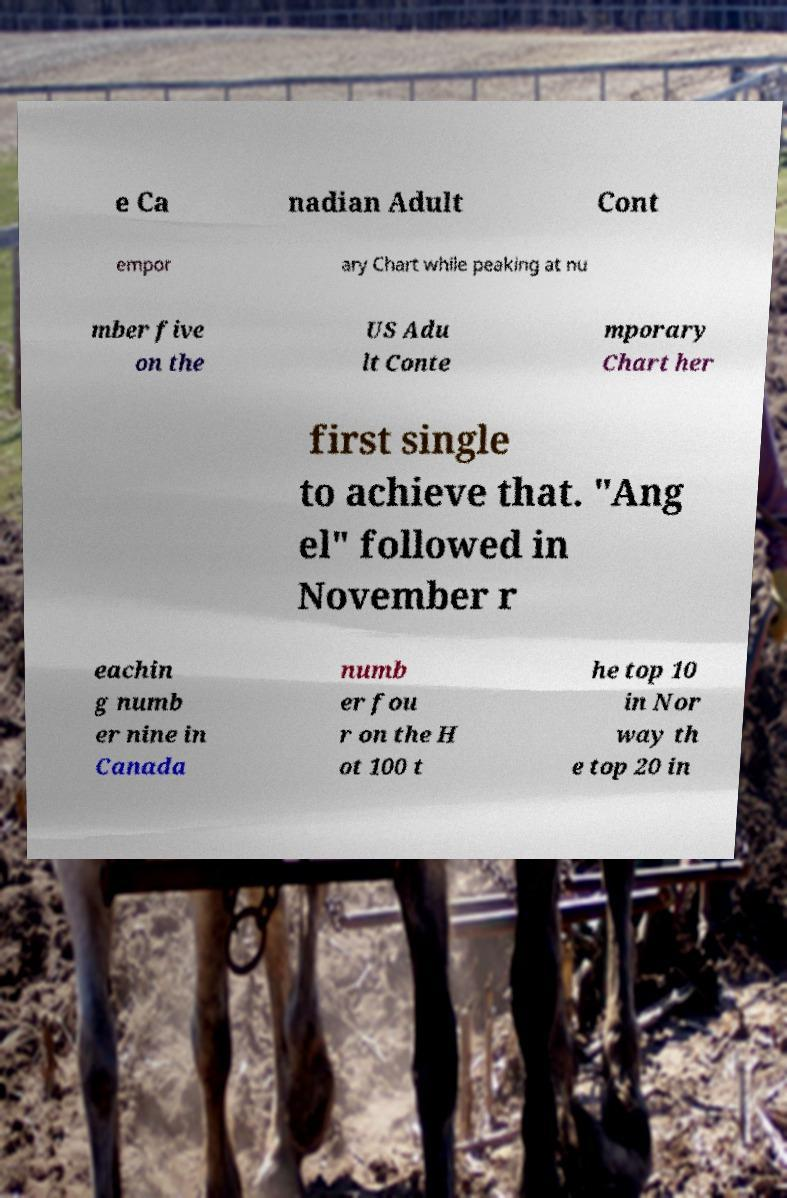Please read and relay the text visible in this image. What does it say? e Ca nadian Adult Cont empor ary Chart while peaking at nu mber five on the US Adu lt Conte mporary Chart her first single to achieve that. "Ang el" followed in November r eachin g numb er nine in Canada numb er fou r on the H ot 100 t he top 10 in Nor way th e top 20 in 